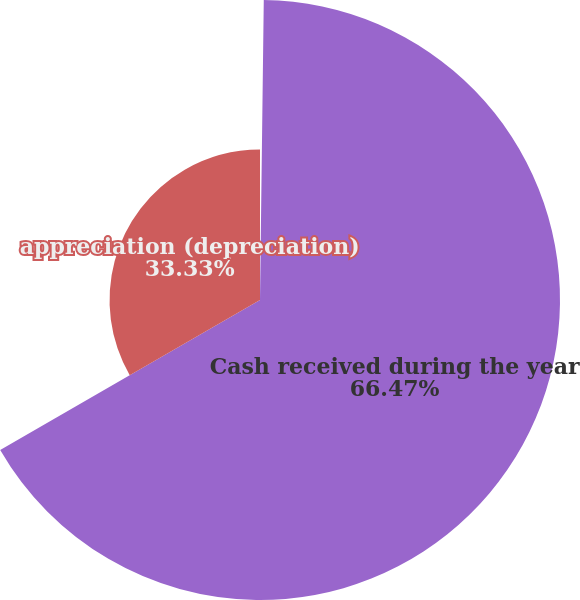Convert chart. <chart><loc_0><loc_0><loc_500><loc_500><pie_chart><fcel>Cash paid during the year for<fcel>Cash received during the year<fcel>appreciation (depreciation)<nl><fcel>0.2%<fcel>66.46%<fcel>33.33%<nl></chart> 